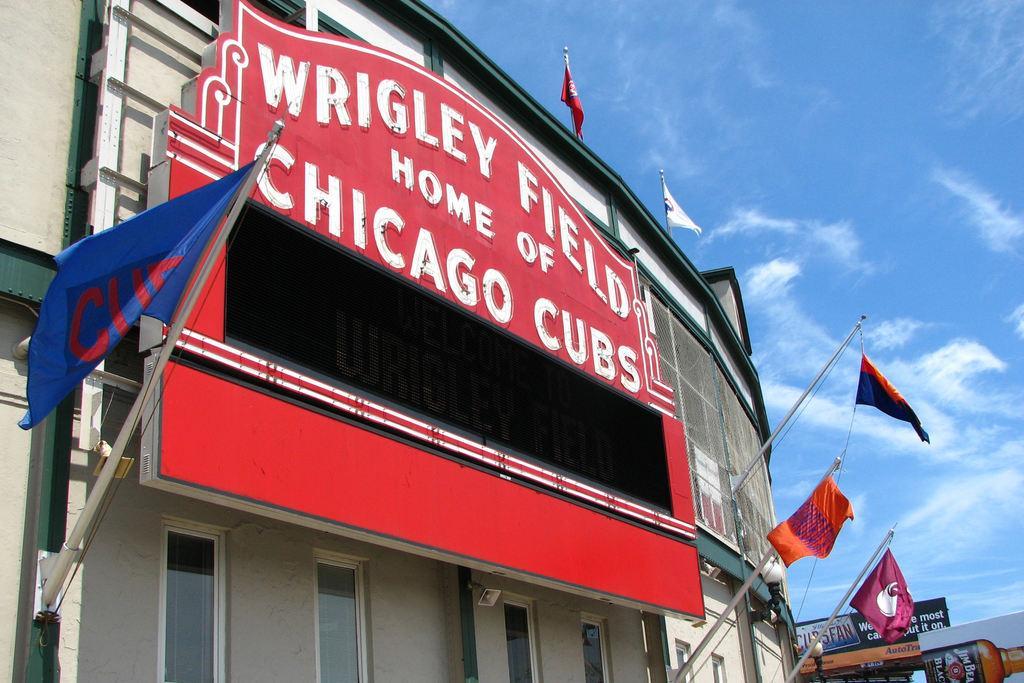In one or two sentences, can you explain what this image depicts? In this image I can see at the bottom there are glass windows, in the middle it looks like a board. There are flags on either side of this image, this is a building. In the right hand side bottom there are hoardings, at the top there is the sky. 